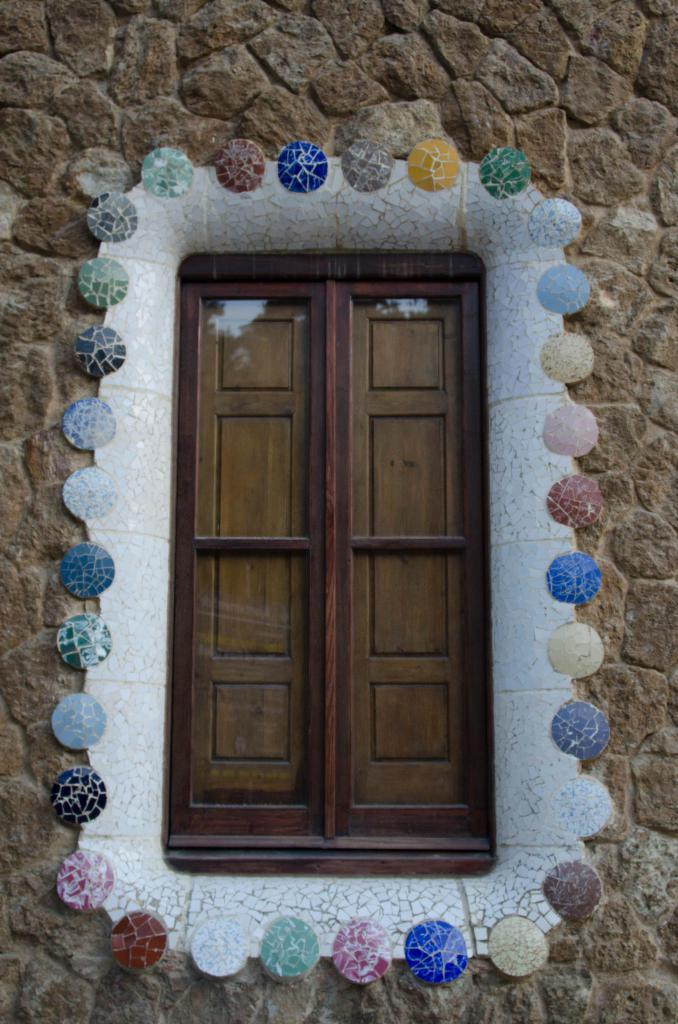What type of door is visible in the image? There is a glass door in the image. What is around the glass door? The glass door has decorative objects around it. What can be said about the colors of the decorative objects? The decorative objects have different colors. What is the glass door attached to? The glass door is on a brick wall. Can you tell me how many snails are crawling on the glass door in the image? There are no snails visible on the glass door in the image. What type of ball is being used to measure the height of the decorative objects? There is no ball or measuring activity present in the image. 